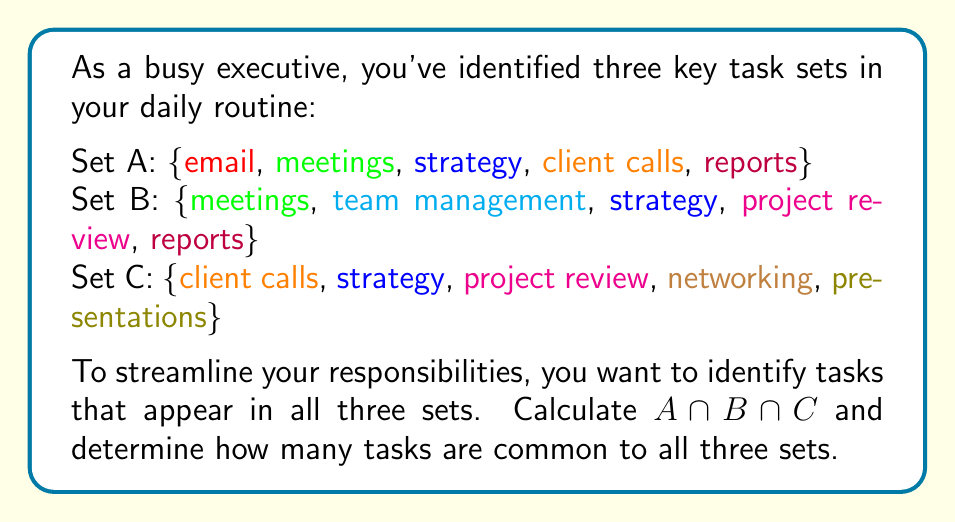Can you answer this question? To solve this problem, we need to find the intersection of all three sets. Let's approach this step-by-step:

1) First, let's write out each set:
   A = $\{email, meetings, strategy, client calls, reports\}$
   B = $\{meetings, team management, strategy, project review, reports\}$
   C = $\{client calls, strategy, project review, networking, presentations\}$

2) To find $A \cap B \cap C$, we need to identify elements that appear in all three sets.

3) Let's start by finding $A \cap B$:
   $A \cap B = \{meetings, strategy, reports\}$

4) Now, let's intersect this result with C:
   $(A \cap B) \cap C = \{strategy\}$

5) Therefore, $A \cap B \cap C = \{strategy\}$

6) To determine how many tasks are common to all three sets, we simply count the elements in $A \cap B \cap C$, which is 1.

This result suggests that "strategy" is the only task that appears in all three sets of your daily routine, indicating it's a core responsibility that spans across different areas of your work.
Answer: $A \cap B \cap C = \{strategy\}$
Number of tasks common to all three sets: 1 